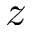<formula> <loc_0><loc_0><loc_500><loc_500>z</formula> 